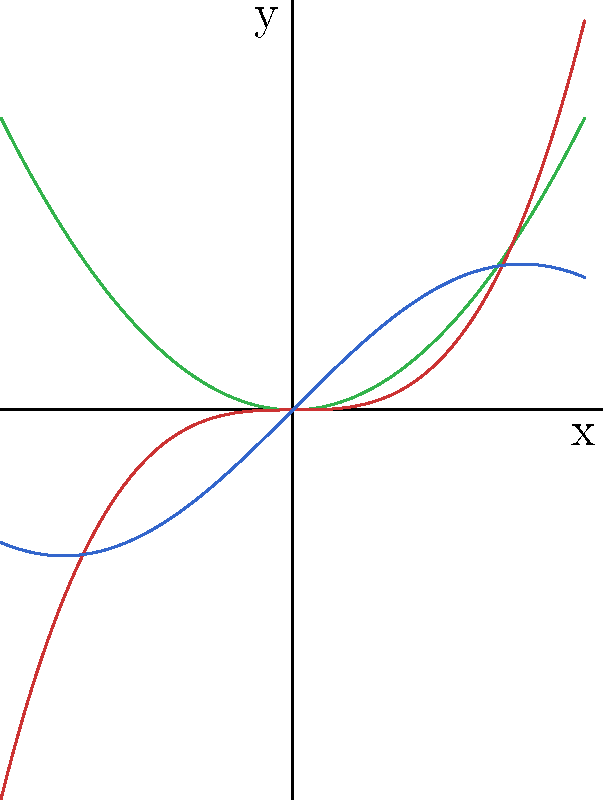In the chart above, three different functions are represented using distinct colors. Which color scheme principle is best exemplified by this representation, and how might you improve it to enhance data clarity for users with color vision deficiencies? 1. Color differentiation: The chart uses three distinct colors (green, red, and blue) to represent different functions, which is a basic principle of color schemes in data visualization.

2. Contrast: The colors chosen have good contrast against each other and the white background, making them easily distinguishable.

3. Color vision deficiency consideration: However, the use of red and green together can be problematic for users with red-green color blindness, the most common type of color vision deficiency.

4. Improving accessibility: To enhance data clarity for users with color vision deficiencies:
   a. Use a more accessible color palette, such as blue, orange, and purple.
   b. Incorporate patterns or textures in addition to colors.
   c. Add labels directly on the lines or use a clearer legend.

5. Color-blind friendly palettes: Tools like ColorBrewer or Viz Palette can help select color schemes that are accessible to people with various types of color vision deficiencies.

6. Testing: Use color blindness simulators to test the effectiveness of the chosen color scheme for different types of color vision deficiencies.

The principle exemplified is color differentiation, but it can be improved by considering color vision deficiencies in the design process.
Answer: Color differentiation; improve by using color-blind friendly palette and adding patterns/textures. 